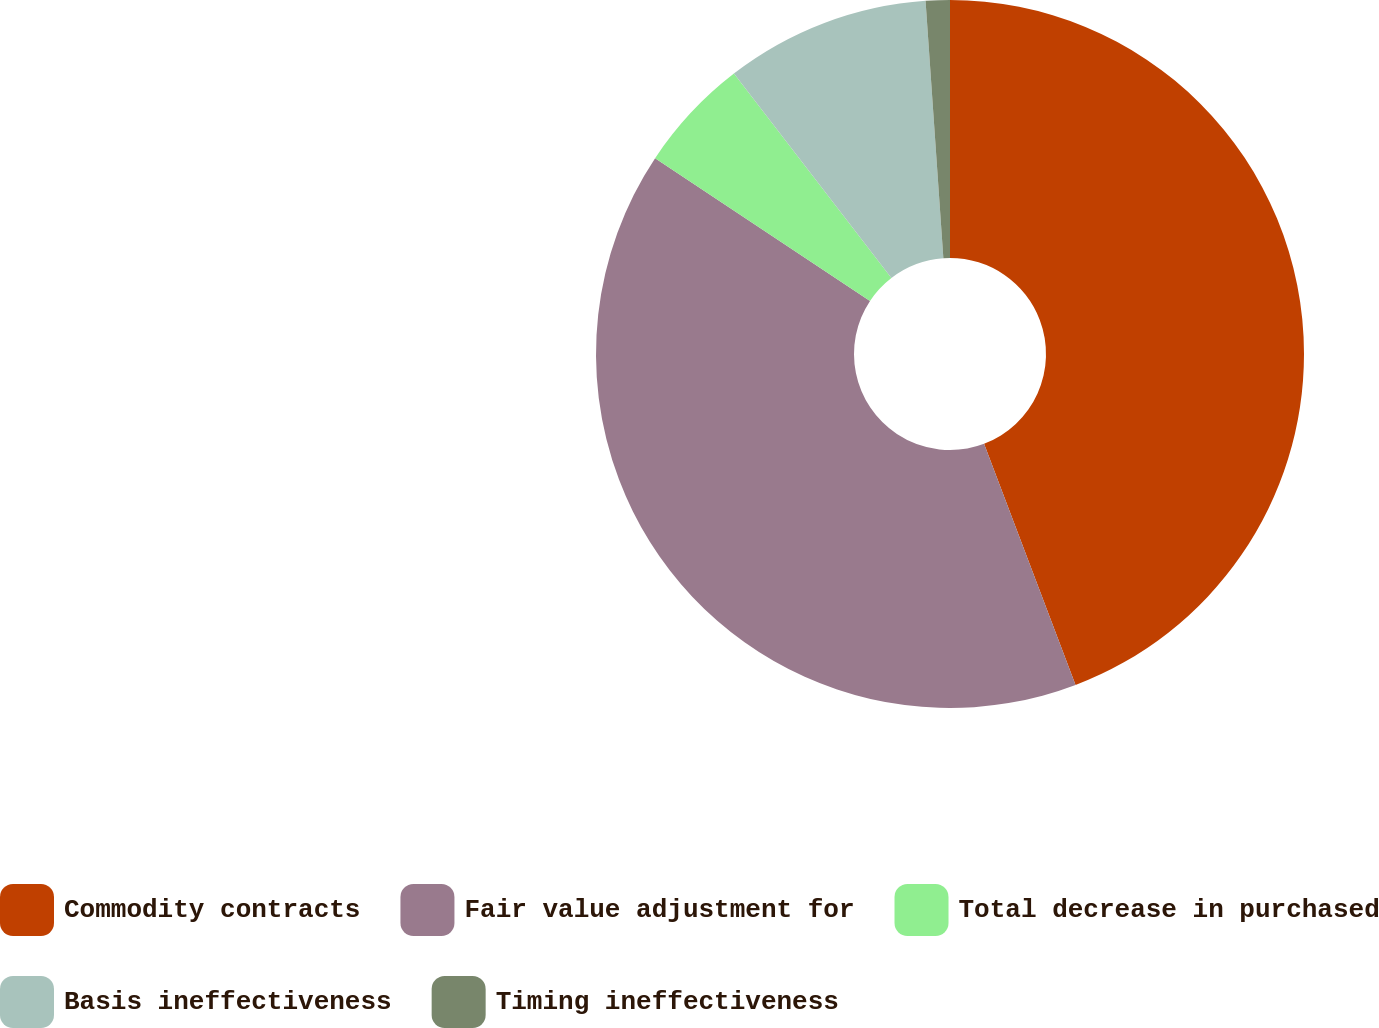Convert chart. <chart><loc_0><loc_0><loc_500><loc_500><pie_chart><fcel>Commodity contracts<fcel>Fair value adjustment for<fcel>Total decrease in purchased<fcel>Basis ineffectiveness<fcel>Timing ineffectiveness<nl><fcel>44.23%<fcel>40.1%<fcel>5.22%<fcel>9.35%<fcel>1.1%<nl></chart> 